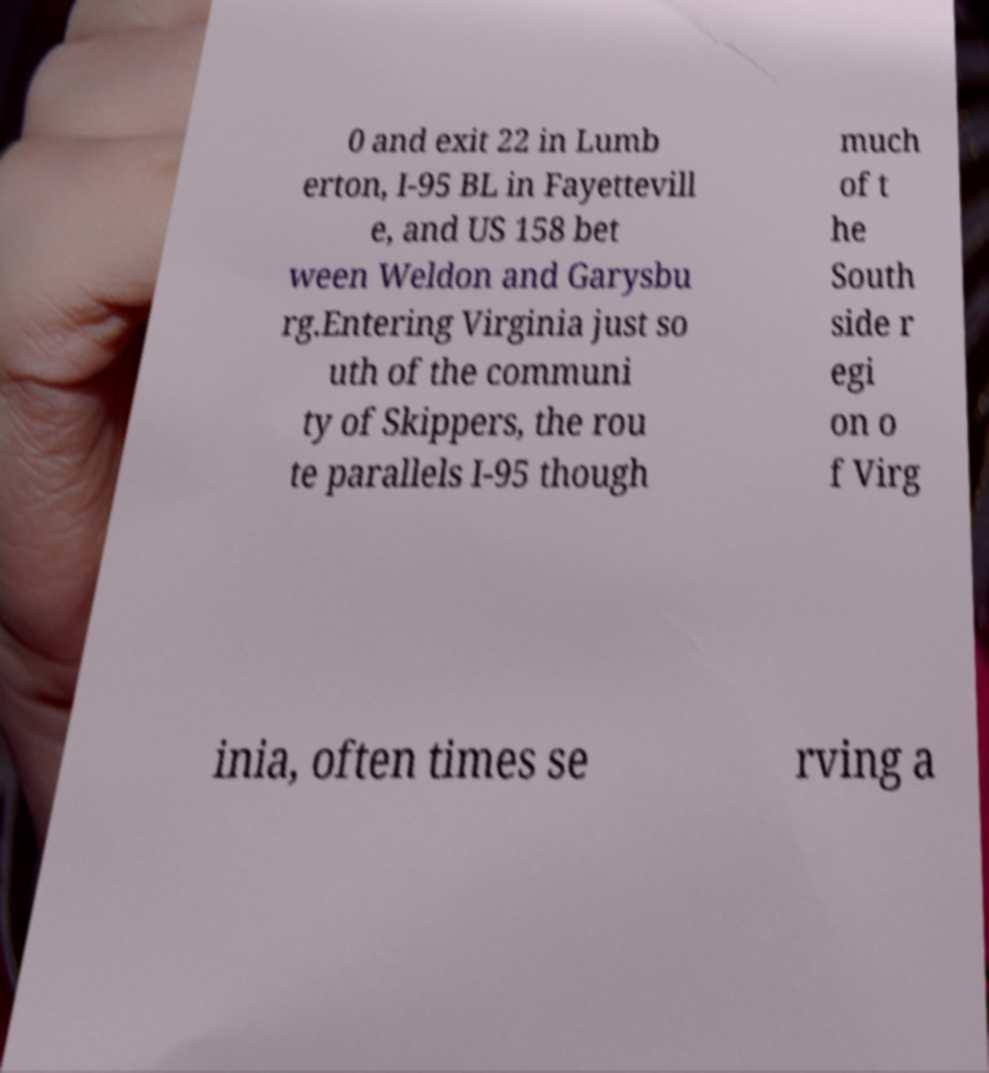There's text embedded in this image that I need extracted. Can you transcribe it verbatim? 0 and exit 22 in Lumb erton, I-95 BL in Fayettevill e, and US 158 bet ween Weldon and Garysbu rg.Entering Virginia just so uth of the communi ty of Skippers, the rou te parallels I-95 though much of t he South side r egi on o f Virg inia, often times se rving a 